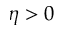<formula> <loc_0><loc_0><loc_500><loc_500>\eta > 0</formula> 